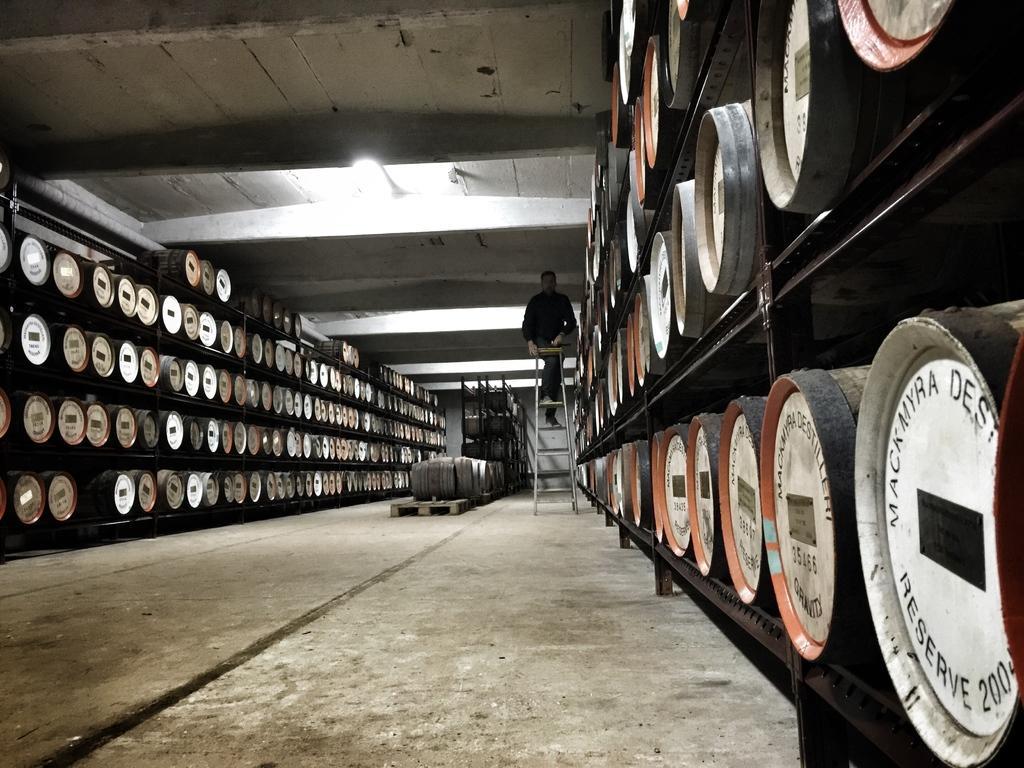Can you describe this image briefly? In this image I can see few drums in the racks and one person is on the ladder. At the top I can see the light and the ceiling. 